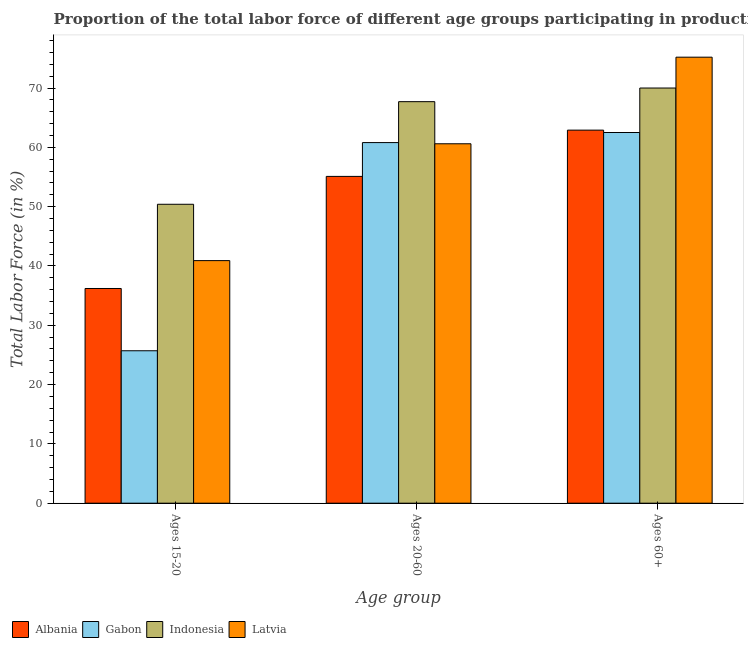How many groups of bars are there?
Keep it short and to the point. 3. What is the label of the 2nd group of bars from the left?
Offer a terse response. Ages 20-60. What is the percentage of labor force within the age group 20-60 in Gabon?
Make the answer very short. 60.8. Across all countries, what is the maximum percentage of labor force within the age group 20-60?
Your answer should be very brief. 67.7. Across all countries, what is the minimum percentage of labor force above age 60?
Your answer should be compact. 62.5. In which country was the percentage of labor force above age 60 maximum?
Provide a short and direct response. Latvia. In which country was the percentage of labor force within the age group 20-60 minimum?
Keep it short and to the point. Albania. What is the total percentage of labor force above age 60 in the graph?
Provide a succinct answer. 270.6. What is the difference between the percentage of labor force within the age group 20-60 in Albania and that in Indonesia?
Your answer should be compact. -12.6. What is the average percentage of labor force within the age group 20-60 per country?
Provide a short and direct response. 61.05. What is the difference between the percentage of labor force within the age group 20-60 and percentage of labor force above age 60 in Indonesia?
Offer a terse response. -2.3. What is the ratio of the percentage of labor force above age 60 in Albania to that in Gabon?
Ensure brevity in your answer.  1.01. Is the difference between the percentage of labor force within the age group 20-60 in Indonesia and Albania greater than the difference between the percentage of labor force within the age group 15-20 in Indonesia and Albania?
Your response must be concise. No. What is the difference between the highest and the lowest percentage of labor force above age 60?
Your answer should be very brief. 12.7. In how many countries, is the percentage of labor force within the age group 20-60 greater than the average percentage of labor force within the age group 20-60 taken over all countries?
Your answer should be compact. 1. What does the 4th bar from the left in Ages 15-20 represents?
Make the answer very short. Latvia. What does the 2nd bar from the right in Ages 60+ represents?
Keep it short and to the point. Indonesia. Is it the case that in every country, the sum of the percentage of labor force within the age group 15-20 and percentage of labor force within the age group 20-60 is greater than the percentage of labor force above age 60?
Your answer should be compact. Yes. How many bars are there?
Offer a very short reply. 12. How many countries are there in the graph?
Your response must be concise. 4. What is the difference between two consecutive major ticks on the Y-axis?
Provide a succinct answer. 10. Are the values on the major ticks of Y-axis written in scientific E-notation?
Provide a succinct answer. No. Does the graph contain grids?
Your answer should be compact. No. Where does the legend appear in the graph?
Provide a short and direct response. Bottom left. How are the legend labels stacked?
Offer a very short reply. Horizontal. What is the title of the graph?
Ensure brevity in your answer.  Proportion of the total labor force of different age groups participating in production in 2013. What is the label or title of the X-axis?
Provide a short and direct response. Age group. What is the label or title of the Y-axis?
Offer a very short reply. Total Labor Force (in %). What is the Total Labor Force (in %) in Albania in Ages 15-20?
Your answer should be compact. 36.2. What is the Total Labor Force (in %) in Gabon in Ages 15-20?
Ensure brevity in your answer.  25.7. What is the Total Labor Force (in %) in Indonesia in Ages 15-20?
Ensure brevity in your answer.  50.4. What is the Total Labor Force (in %) in Latvia in Ages 15-20?
Keep it short and to the point. 40.9. What is the Total Labor Force (in %) of Albania in Ages 20-60?
Your response must be concise. 55.1. What is the Total Labor Force (in %) of Gabon in Ages 20-60?
Ensure brevity in your answer.  60.8. What is the Total Labor Force (in %) of Indonesia in Ages 20-60?
Your response must be concise. 67.7. What is the Total Labor Force (in %) of Latvia in Ages 20-60?
Keep it short and to the point. 60.6. What is the Total Labor Force (in %) of Albania in Ages 60+?
Provide a short and direct response. 62.9. What is the Total Labor Force (in %) of Gabon in Ages 60+?
Keep it short and to the point. 62.5. What is the Total Labor Force (in %) in Indonesia in Ages 60+?
Your answer should be very brief. 70. What is the Total Labor Force (in %) of Latvia in Ages 60+?
Ensure brevity in your answer.  75.2. Across all Age group, what is the maximum Total Labor Force (in %) in Albania?
Offer a terse response. 62.9. Across all Age group, what is the maximum Total Labor Force (in %) of Gabon?
Your answer should be very brief. 62.5. Across all Age group, what is the maximum Total Labor Force (in %) in Latvia?
Your answer should be very brief. 75.2. Across all Age group, what is the minimum Total Labor Force (in %) of Albania?
Ensure brevity in your answer.  36.2. Across all Age group, what is the minimum Total Labor Force (in %) in Gabon?
Give a very brief answer. 25.7. Across all Age group, what is the minimum Total Labor Force (in %) in Indonesia?
Offer a terse response. 50.4. Across all Age group, what is the minimum Total Labor Force (in %) in Latvia?
Your answer should be compact. 40.9. What is the total Total Labor Force (in %) of Albania in the graph?
Keep it short and to the point. 154.2. What is the total Total Labor Force (in %) in Gabon in the graph?
Offer a terse response. 149. What is the total Total Labor Force (in %) in Indonesia in the graph?
Make the answer very short. 188.1. What is the total Total Labor Force (in %) of Latvia in the graph?
Give a very brief answer. 176.7. What is the difference between the Total Labor Force (in %) of Albania in Ages 15-20 and that in Ages 20-60?
Your answer should be compact. -18.9. What is the difference between the Total Labor Force (in %) of Gabon in Ages 15-20 and that in Ages 20-60?
Offer a very short reply. -35.1. What is the difference between the Total Labor Force (in %) in Indonesia in Ages 15-20 and that in Ages 20-60?
Keep it short and to the point. -17.3. What is the difference between the Total Labor Force (in %) in Latvia in Ages 15-20 and that in Ages 20-60?
Your response must be concise. -19.7. What is the difference between the Total Labor Force (in %) of Albania in Ages 15-20 and that in Ages 60+?
Ensure brevity in your answer.  -26.7. What is the difference between the Total Labor Force (in %) in Gabon in Ages 15-20 and that in Ages 60+?
Ensure brevity in your answer.  -36.8. What is the difference between the Total Labor Force (in %) of Indonesia in Ages 15-20 and that in Ages 60+?
Your answer should be compact. -19.6. What is the difference between the Total Labor Force (in %) of Latvia in Ages 15-20 and that in Ages 60+?
Make the answer very short. -34.3. What is the difference between the Total Labor Force (in %) in Gabon in Ages 20-60 and that in Ages 60+?
Your answer should be very brief. -1.7. What is the difference between the Total Labor Force (in %) of Latvia in Ages 20-60 and that in Ages 60+?
Keep it short and to the point. -14.6. What is the difference between the Total Labor Force (in %) of Albania in Ages 15-20 and the Total Labor Force (in %) of Gabon in Ages 20-60?
Your answer should be compact. -24.6. What is the difference between the Total Labor Force (in %) in Albania in Ages 15-20 and the Total Labor Force (in %) in Indonesia in Ages 20-60?
Keep it short and to the point. -31.5. What is the difference between the Total Labor Force (in %) of Albania in Ages 15-20 and the Total Labor Force (in %) of Latvia in Ages 20-60?
Keep it short and to the point. -24.4. What is the difference between the Total Labor Force (in %) in Gabon in Ages 15-20 and the Total Labor Force (in %) in Indonesia in Ages 20-60?
Offer a very short reply. -42. What is the difference between the Total Labor Force (in %) of Gabon in Ages 15-20 and the Total Labor Force (in %) of Latvia in Ages 20-60?
Keep it short and to the point. -34.9. What is the difference between the Total Labor Force (in %) in Albania in Ages 15-20 and the Total Labor Force (in %) in Gabon in Ages 60+?
Your response must be concise. -26.3. What is the difference between the Total Labor Force (in %) in Albania in Ages 15-20 and the Total Labor Force (in %) in Indonesia in Ages 60+?
Provide a short and direct response. -33.8. What is the difference between the Total Labor Force (in %) in Albania in Ages 15-20 and the Total Labor Force (in %) in Latvia in Ages 60+?
Offer a terse response. -39. What is the difference between the Total Labor Force (in %) of Gabon in Ages 15-20 and the Total Labor Force (in %) of Indonesia in Ages 60+?
Ensure brevity in your answer.  -44.3. What is the difference between the Total Labor Force (in %) in Gabon in Ages 15-20 and the Total Labor Force (in %) in Latvia in Ages 60+?
Your answer should be compact. -49.5. What is the difference between the Total Labor Force (in %) in Indonesia in Ages 15-20 and the Total Labor Force (in %) in Latvia in Ages 60+?
Provide a succinct answer. -24.8. What is the difference between the Total Labor Force (in %) in Albania in Ages 20-60 and the Total Labor Force (in %) in Indonesia in Ages 60+?
Your answer should be very brief. -14.9. What is the difference between the Total Labor Force (in %) of Albania in Ages 20-60 and the Total Labor Force (in %) of Latvia in Ages 60+?
Keep it short and to the point. -20.1. What is the difference between the Total Labor Force (in %) in Gabon in Ages 20-60 and the Total Labor Force (in %) in Latvia in Ages 60+?
Your answer should be very brief. -14.4. What is the difference between the Total Labor Force (in %) in Indonesia in Ages 20-60 and the Total Labor Force (in %) in Latvia in Ages 60+?
Make the answer very short. -7.5. What is the average Total Labor Force (in %) in Albania per Age group?
Offer a terse response. 51.4. What is the average Total Labor Force (in %) in Gabon per Age group?
Ensure brevity in your answer.  49.67. What is the average Total Labor Force (in %) of Indonesia per Age group?
Offer a terse response. 62.7. What is the average Total Labor Force (in %) of Latvia per Age group?
Offer a very short reply. 58.9. What is the difference between the Total Labor Force (in %) of Albania and Total Labor Force (in %) of Latvia in Ages 15-20?
Your response must be concise. -4.7. What is the difference between the Total Labor Force (in %) of Gabon and Total Labor Force (in %) of Indonesia in Ages 15-20?
Your response must be concise. -24.7. What is the difference between the Total Labor Force (in %) of Gabon and Total Labor Force (in %) of Latvia in Ages 15-20?
Keep it short and to the point. -15.2. What is the difference between the Total Labor Force (in %) in Indonesia and Total Labor Force (in %) in Latvia in Ages 15-20?
Give a very brief answer. 9.5. What is the difference between the Total Labor Force (in %) of Albania and Total Labor Force (in %) of Gabon in Ages 20-60?
Your answer should be compact. -5.7. What is the difference between the Total Labor Force (in %) in Albania and Total Labor Force (in %) in Latvia in Ages 20-60?
Make the answer very short. -5.5. What is the difference between the Total Labor Force (in %) of Gabon and Total Labor Force (in %) of Indonesia in Ages 20-60?
Your answer should be very brief. -6.9. What is the difference between the Total Labor Force (in %) in Gabon and Total Labor Force (in %) in Latvia in Ages 20-60?
Provide a short and direct response. 0.2. What is the difference between the Total Labor Force (in %) of Albania and Total Labor Force (in %) of Indonesia in Ages 60+?
Give a very brief answer. -7.1. What is the difference between the Total Labor Force (in %) in Gabon and Total Labor Force (in %) in Indonesia in Ages 60+?
Provide a succinct answer. -7.5. What is the difference between the Total Labor Force (in %) in Indonesia and Total Labor Force (in %) in Latvia in Ages 60+?
Give a very brief answer. -5.2. What is the ratio of the Total Labor Force (in %) in Albania in Ages 15-20 to that in Ages 20-60?
Offer a very short reply. 0.66. What is the ratio of the Total Labor Force (in %) of Gabon in Ages 15-20 to that in Ages 20-60?
Provide a succinct answer. 0.42. What is the ratio of the Total Labor Force (in %) of Indonesia in Ages 15-20 to that in Ages 20-60?
Your response must be concise. 0.74. What is the ratio of the Total Labor Force (in %) of Latvia in Ages 15-20 to that in Ages 20-60?
Ensure brevity in your answer.  0.67. What is the ratio of the Total Labor Force (in %) in Albania in Ages 15-20 to that in Ages 60+?
Provide a short and direct response. 0.58. What is the ratio of the Total Labor Force (in %) in Gabon in Ages 15-20 to that in Ages 60+?
Your response must be concise. 0.41. What is the ratio of the Total Labor Force (in %) in Indonesia in Ages 15-20 to that in Ages 60+?
Provide a short and direct response. 0.72. What is the ratio of the Total Labor Force (in %) in Latvia in Ages 15-20 to that in Ages 60+?
Offer a very short reply. 0.54. What is the ratio of the Total Labor Force (in %) of Albania in Ages 20-60 to that in Ages 60+?
Your response must be concise. 0.88. What is the ratio of the Total Labor Force (in %) in Gabon in Ages 20-60 to that in Ages 60+?
Your response must be concise. 0.97. What is the ratio of the Total Labor Force (in %) in Indonesia in Ages 20-60 to that in Ages 60+?
Make the answer very short. 0.97. What is the ratio of the Total Labor Force (in %) in Latvia in Ages 20-60 to that in Ages 60+?
Provide a short and direct response. 0.81. What is the difference between the highest and the second highest Total Labor Force (in %) of Albania?
Give a very brief answer. 7.8. What is the difference between the highest and the second highest Total Labor Force (in %) of Indonesia?
Your answer should be very brief. 2.3. What is the difference between the highest and the lowest Total Labor Force (in %) in Albania?
Provide a short and direct response. 26.7. What is the difference between the highest and the lowest Total Labor Force (in %) in Gabon?
Provide a short and direct response. 36.8. What is the difference between the highest and the lowest Total Labor Force (in %) of Indonesia?
Make the answer very short. 19.6. What is the difference between the highest and the lowest Total Labor Force (in %) of Latvia?
Provide a short and direct response. 34.3. 